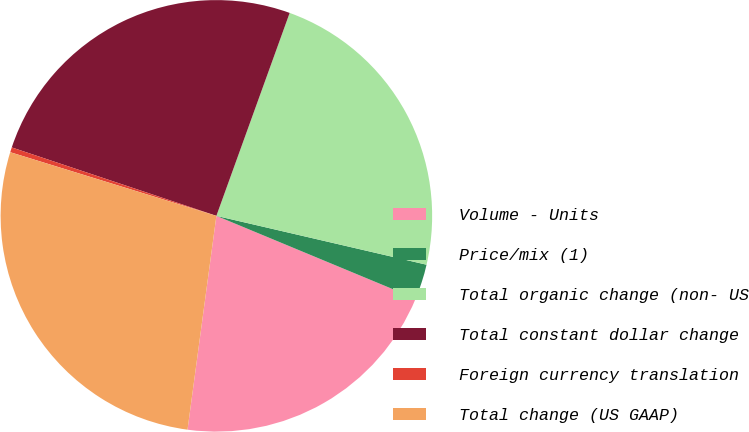<chart> <loc_0><loc_0><loc_500><loc_500><pie_chart><fcel>Volume - Units<fcel>Price/mix (1)<fcel>Total organic change (non- US<fcel>Total constant dollar change<fcel>Foreign currency translation<fcel>Total change (US GAAP)<nl><fcel>20.87%<fcel>2.63%<fcel>23.12%<fcel>25.38%<fcel>0.37%<fcel>27.63%<nl></chart> 